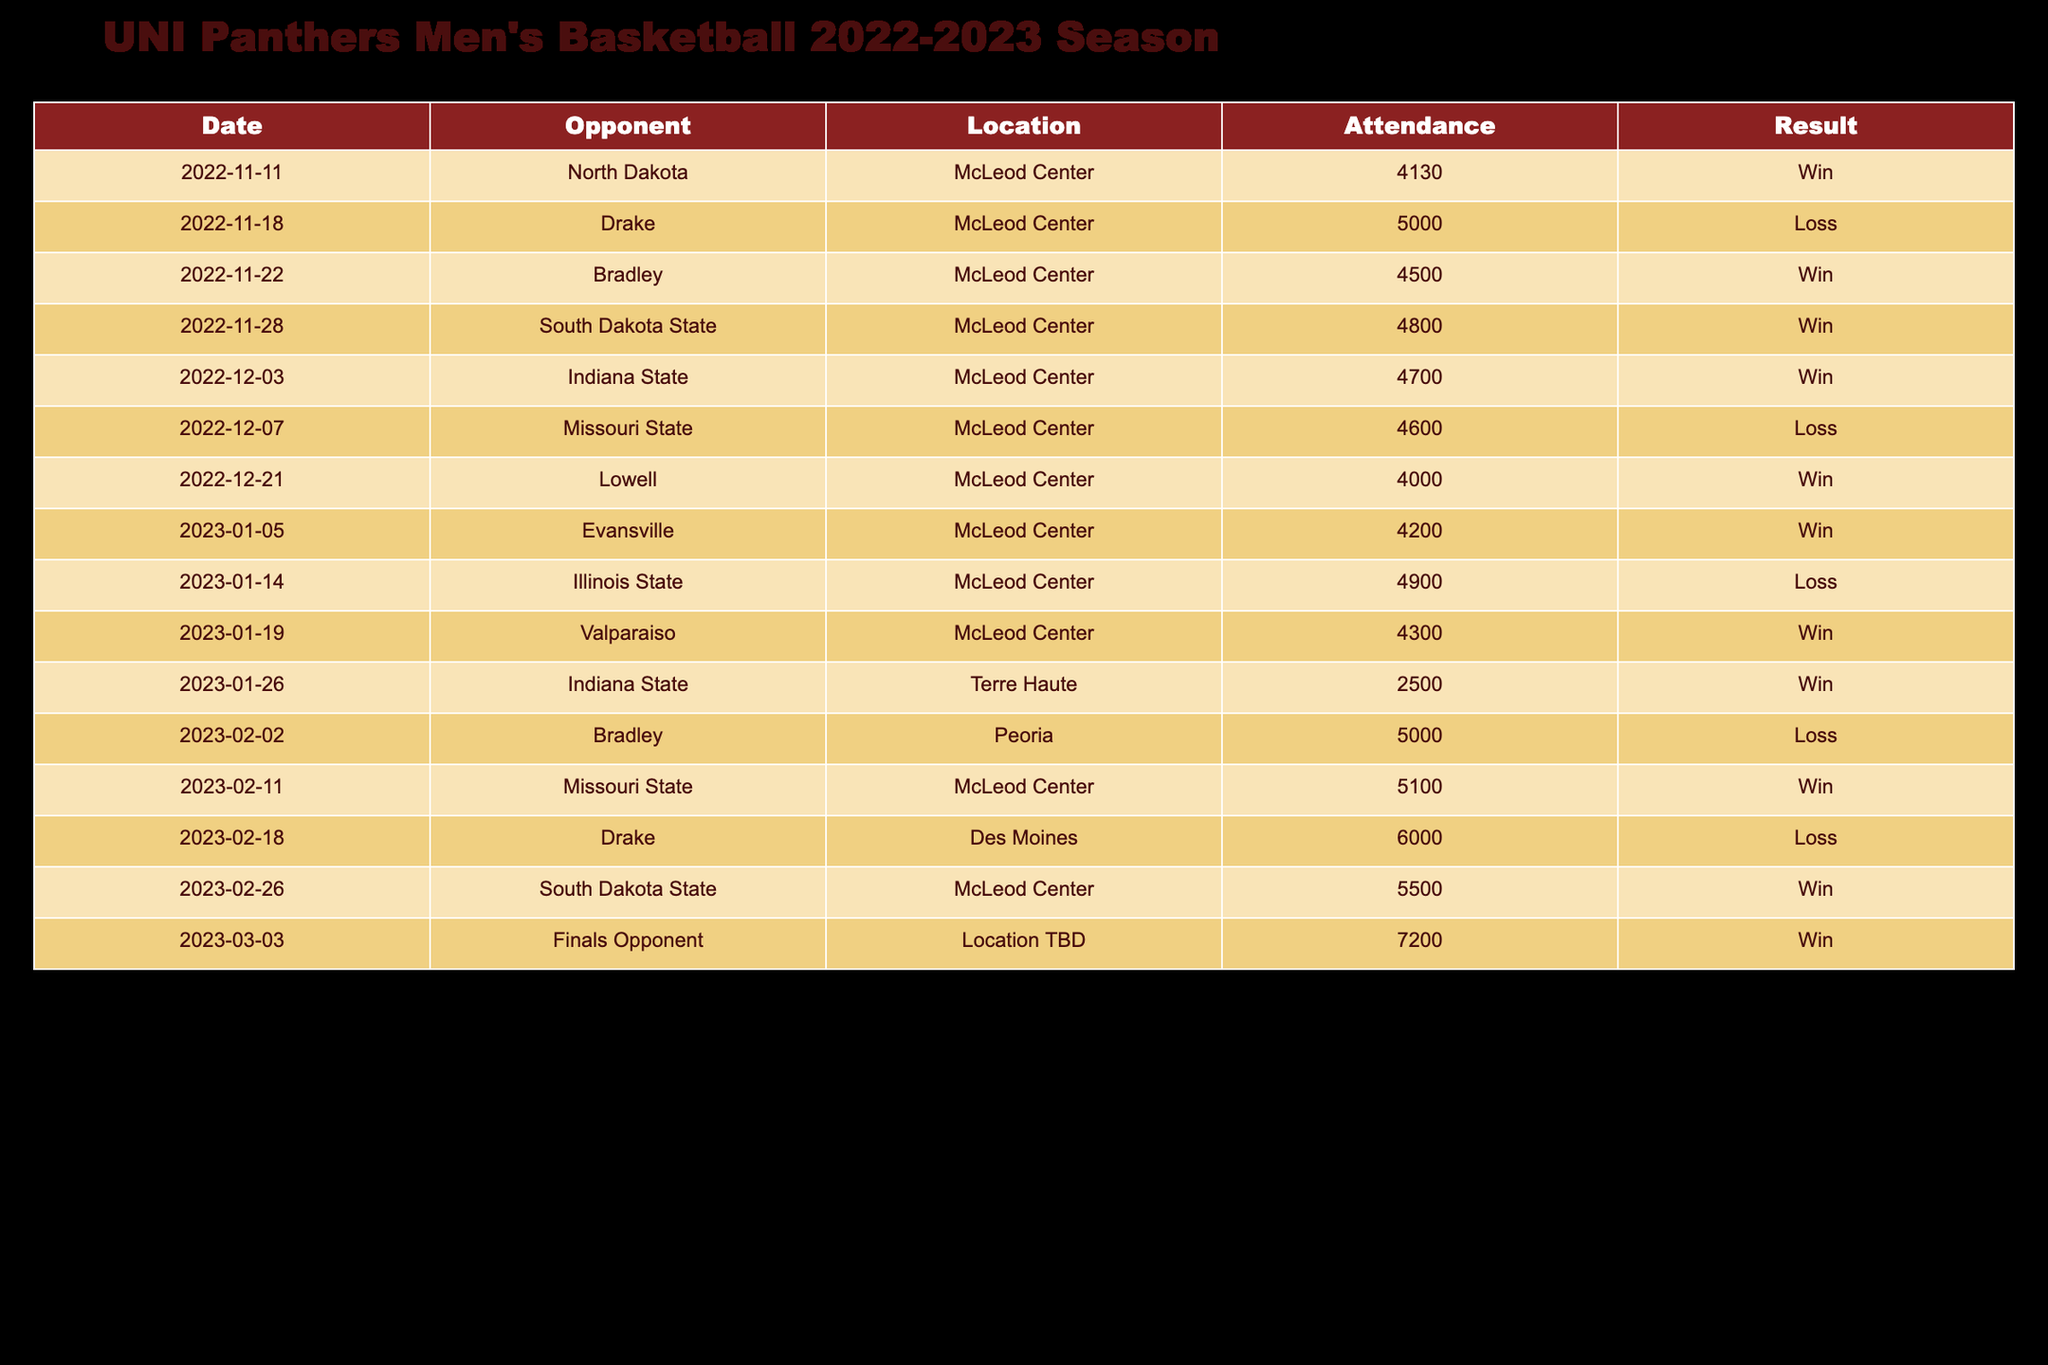What was the highest attendance recorded during the season? The attendance numbers range from 2500 to 7200. Checking through the row data, the maximum value is 7200 on March 3.
Answer: 7200 What was the average attendance of all home games? The attendance for home games is: 4130, 5000, 4500, 4800, 4700, 4600, 4000, 4200, 4900, 5100, 5500. Adding them up gives  4130 + 5000 + 4500 + 4800 + 4700 + 4600 + 4000 + 4200 + 4900 + 5100 =  49130. There are 10 games, so the average is 49130 / 10 = 4913.
Answer: 4913 Did the team win more games than they lost at home? The team won 7 out of the 11 home games (7 wins: North Dakota, Bradley, South Dakota State, Indiana State, Lowell, Missouri State, South Dakota State; 4 losses: Drake, Missouri State, Illinois State, Drake). Therefore, yes, they won more games than they lost at home.
Answer: Yes What was the total attendance for games played in January? The attendances for January games are: 4200 (Evansville), 4900 (Illinois State), and 4300 (Valparaiso). Adding them gives 4200 + 4900 + 4300 = 13400, which is the total attendance for January.
Answer: 13400 What was the win-loss ratio for games played against Drake? The UNI Panthers played against Drake twice, once at home and once at a neutral site. They lost both games. Therefore, the win-loss ratio is 0 wins to 2 losses, which can be expressed as 0:2.
Answer: 0:2 How many games were played at the McLeod Center during the season? Counting the rows for games played at the McLeod Center, there are 11 instances (every game except the two played at Terre Haute and Peoria). Thus, there were 11 games played at the McLeod Center.
Answer: 11 What is the difference in attendance between the game against South Dakota State on February 26 and the game against Illinois State on January 14? The attendance for South Dakota State on February 26 was 5500, while for Illinois State on January 14 it was 4900. The difference is 5500 - 4900 = 600.
Answer: 600 What percentage of the games resulted in wins for the team? The team won 15 out of 17 games. To find the percentage, divide 15 by 17 and multiply by 100, which results in (15/17) * 100 ≈ 88.24%.
Answer: 88.24% 